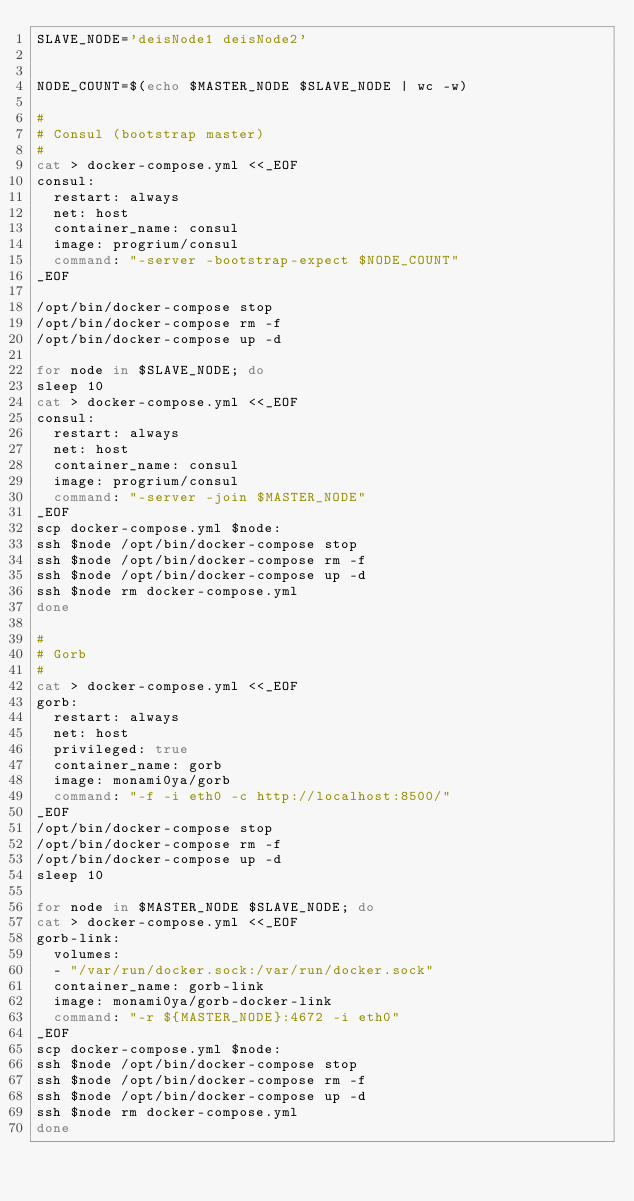<code> <loc_0><loc_0><loc_500><loc_500><_Bash_>SLAVE_NODE='deisNode1 deisNode2'


NODE_COUNT=$(echo $MASTER_NODE $SLAVE_NODE | wc -w)

#
# Consul (bootstrap master)
#
cat > docker-compose.yml <<_EOF
consul:
  restart: always
  net: host
  container_name: consul
  image: progrium/consul
  command: "-server -bootstrap-expect $NODE_COUNT"
_EOF

/opt/bin/docker-compose stop
/opt/bin/docker-compose rm -f
/opt/bin/docker-compose up -d

for node in $SLAVE_NODE; do
sleep 10
cat > docker-compose.yml <<_EOF
consul:
  restart: always
  net: host
  container_name: consul
  image: progrium/consul
  command: "-server -join $MASTER_NODE"
_EOF
scp docker-compose.yml $node:
ssh $node /opt/bin/docker-compose stop
ssh $node /opt/bin/docker-compose rm -f
ssh $node /opt/bin/docker-compose up -d
ssh $node rm docker-compose.yml
done

#
# Gorb
#
cat > docker-compose.yml <<_EOF
gorb:
  restart: always
  net: host
  privileged: true
  container_name: gorb
  image: monami0ya/gorb
  command: "-f -i eth0 -c http://localhost:8500/"
_EOF
/opt/bin/docker-compose stop
/opt/bin/docker-compose rm -f
/opt/bin/docker-compose up -d
sleep 10

for node in $MASTER_NODE $SLAVE_NODE; do
cat > docker-compose.yml <<_EOF
gorb-link:
  volumes:
  - "/var/run/docker.sock:/var/run/docker.sock"
  container_name: gorb-link
  image: monami0ya/gorb-docker-link
  command: "-r ${MASTER_NODE}:4672 -i eth0"
_EOF
scp docker-compose.yml $node:
ssh $node /opt/bin/docker-compose stop
ssh $node /opt/bin/docker-compose rm -f
ssh $node /opt/bin/docker-compose up -d
ssh $node rm docker-compose.yml
done

</code> 